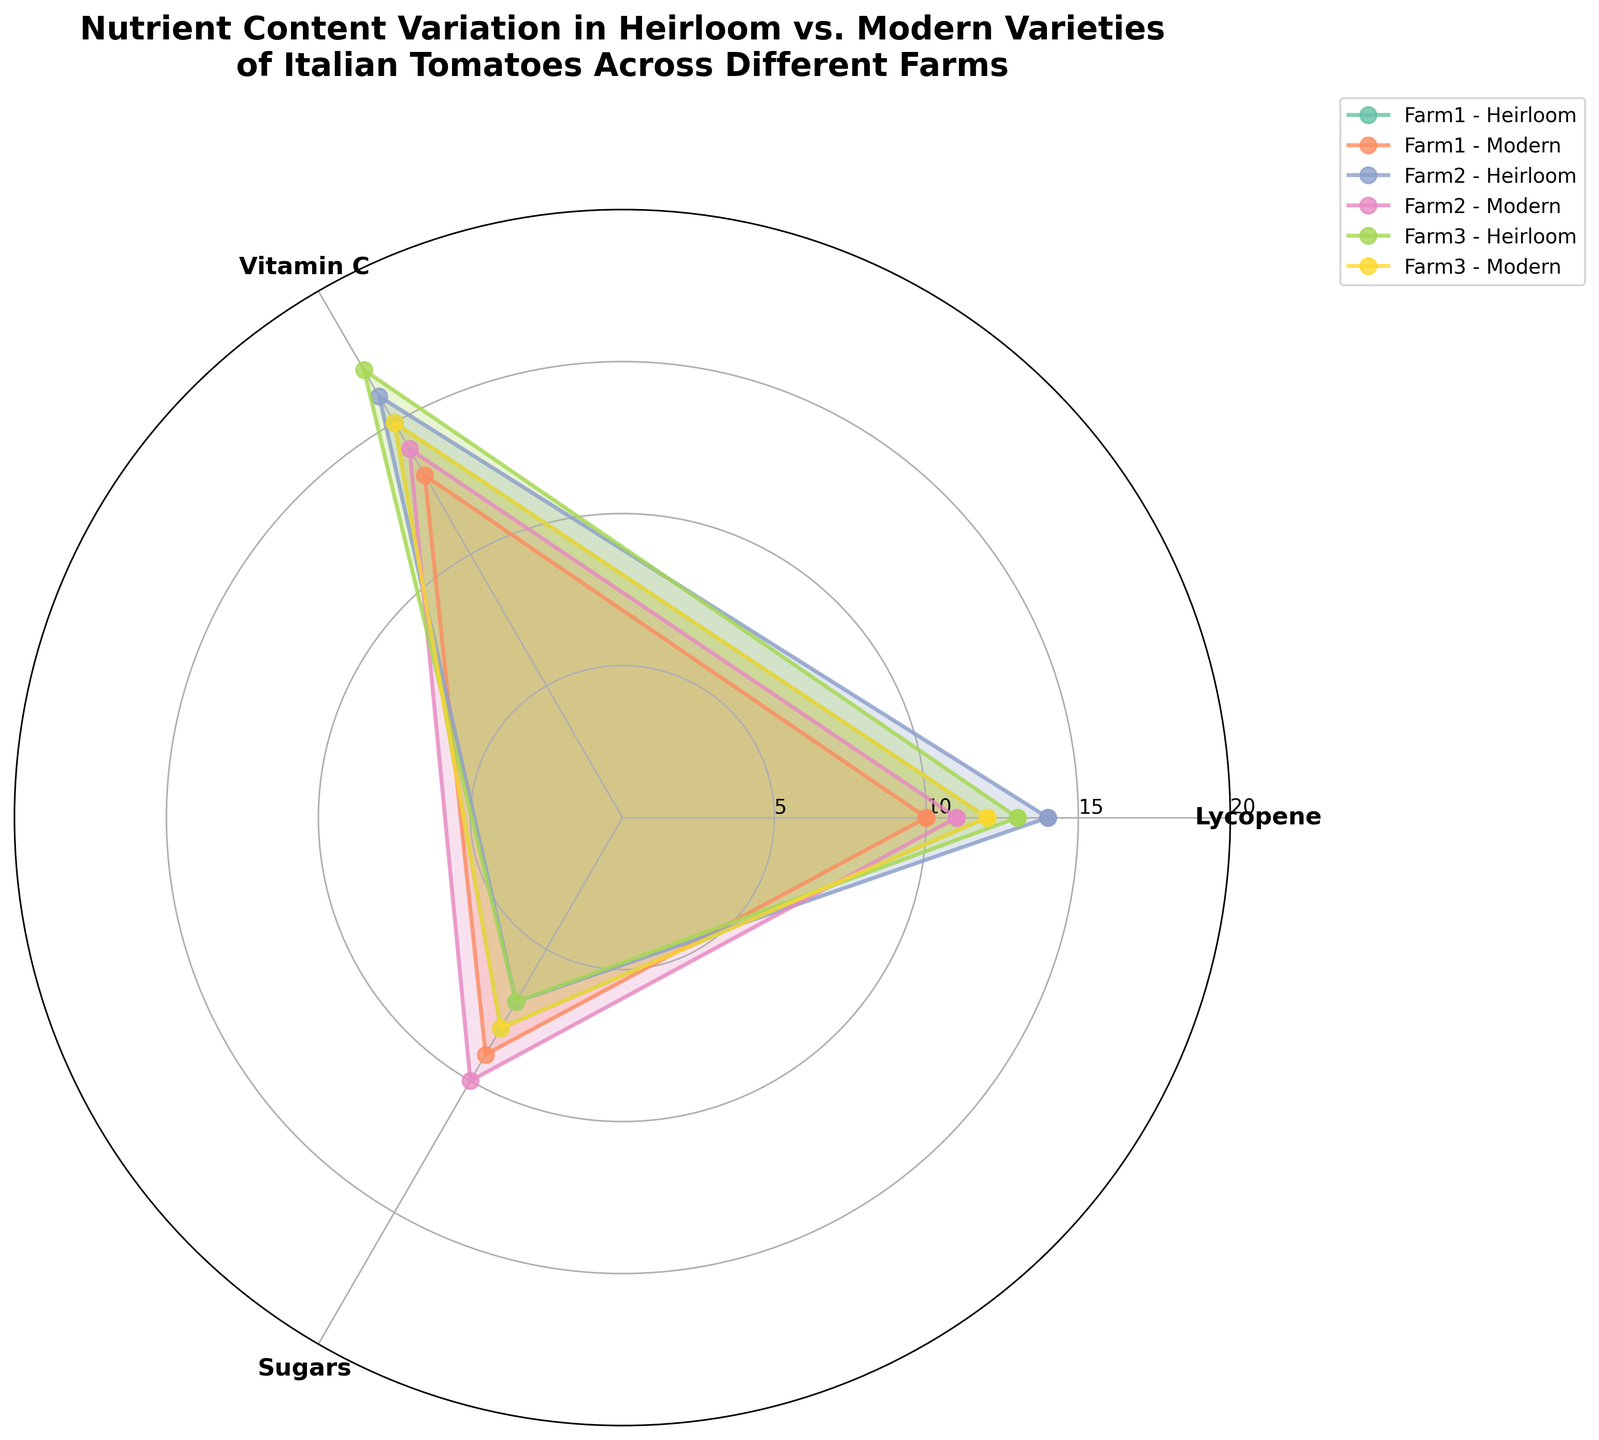What's the title of the figure? The title is displayed at the top of the figure. To find it, look for prominently displayed text. The title is "Nutrient Content Variation in Heirloom vs. Modern Varieties of Italian Tomatoes Across Different Farms".
Answer: Nutrient Content Variation in Heirloom vs. Modern Varieties of Italian Tomatoes Across Different Farms How many nutrient types are compared in the figure? By examining the number of labels on the circular axis, we can count the different nutrients listed. There are three nutrients: Lycopene, Vitamin C, and Sugars.
Answer: 3 Which farm has the lowest Lycopene value for Modern varieties? To find this, examine the radial lines corresponding to Lycopene and look for the lowest value among the three Modern varieties. Farm1 Modern variety has the lowest Lycopene value at 10.
Answer: Farm1 Compare the Vitamin C content between Heirloom and Modern varieties for Farm2. Which variety has a higher value? Locate Farm2 on the plot, then compare the points corresponding to Vitamin C for both Heirloom and Modern varieties. The Heirloom variety has a value of 16, while the Modern variety has a value of 14. Hence, Heirloom has a higher Vitamin C content.
Answer: Heirloom What is the average Sugars content across all farms for Modern varieties? To find the average, sum the Sugars values for Modern varieties across all farms and divide by the number of farms. The values are 9 (Farm1), 10 (Farm2), and 8 (Farm3). So, (9+10+8)/3 = 27/3 = 9.
Answer: 9 Which nutrient shows the greatest variation in values between Heirloom and Modern varieties across all farms? Examine the spread of values for each nutrient separately and compare the differences between Heirloom and Modern varieties across all farms. Lycopene values for Heirloom range from 12 to 14 and Modern from 10 to 12. Vitamin C ranges from 15 to 17 for Heirloom and 13 to 15 for Modern. Sugars ranges from 7 to 8 for Heirloom and 8 to 10 for Modern. Lycopene shows the greatest variation overall.
Answer: Lycopene How does the Nutrient content of Farm3 Heirloom tomatoes for Lycopene compare to Farm1 Heirloom tomatoes for Lycopene? Find the radial lines representing Lycopene for Farm3 and Farm1 Heirloom varieties and compare their lengths. Farm3 Heirloom Lycopene value is 13, Farm1 Heirloom Lycopene value is 12. Farm3 Heirloom has a higher Lycopene value by 1.
Answer: 1 higher What is the total Vitamin C content across all Heirloom varieties? Summing the Vitamin C content for Heirloom varieties across all farms: 15 (Farm1) + 16 (Farm2) + 17 (Farm3) = 48.
Answer: 48 Which farm has the highest average nutrient value for Heirloom varieties? To find the average, sum the values for each nutrient in Heirloom varieties for each farm and divide by the number of nutrients. Farm1: (12+15+8)/3 = 35/3 ≈ 11.67, Farm2: (14+16+7)/3 = 37/3 ≈ 12.33, Farm3: (13+17+7)/3 = 37/3 ≈ 12.33. Farm2 and Farm3 both have the highest average of approximately 12.33.
Answer: Farm2 and Farm3 Is there any nutrient for which Heirloom and Modern varieties have the same content value for any farm? Compare each nutrient for Heirloom and Modern varieties farm by farm. There are no instances where Heirloom and Modern varieties have the same value for any nutrient at any farm.
Answer: No 